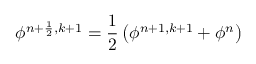<formula> <loc_0><loc_0><loc_500><loc_500>\phi ^ { n + \frac { 1 } { 2 } , k + 1 } = \frac { 1 } { 2 } \left ( \phi ^ { n + 1 , k + 1 } + \phi ^ { n } \right )</formula> 